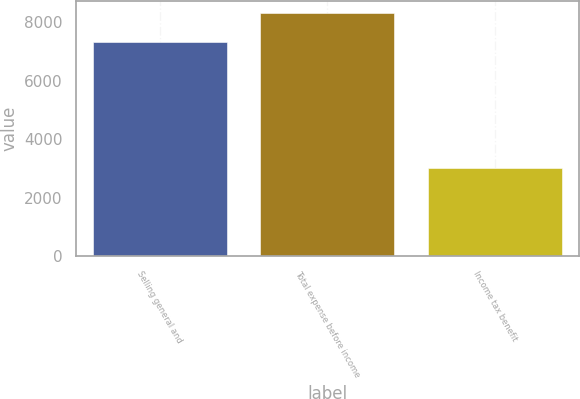Convert chart to OTSL. <chart><loc_0><loc_0><loc_500><loc_500><bar_chart><fcel>Selling general and<fcel>Total expense before income<fcel>Income tax benefit<nl><fcel>7330<fcel>8329<fcel>3032<nl></chart> 